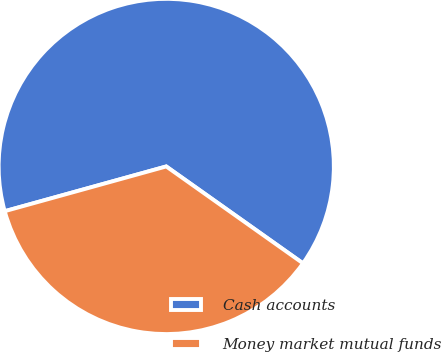Convert chart to OTSL. <chart><loc_0><loc_0><loc_500><loc_500><pie_chart><fcel>Cash accounts<fcel>Money market mutual funds<nl><fcel>64.11%<fcel>35.89%<nl></chart> 